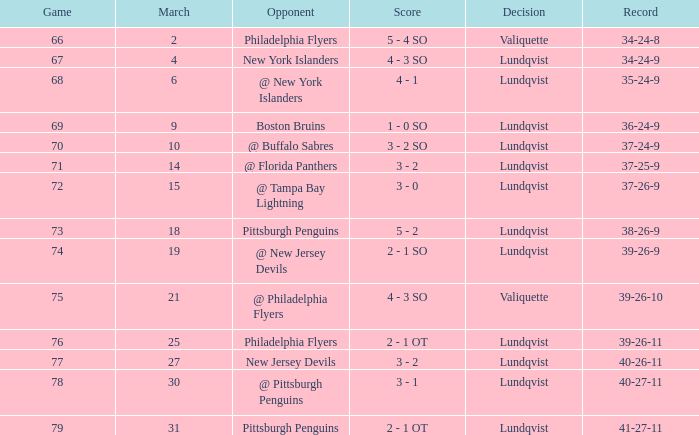Which opponent's game was less than 76 when the march was 10? @ Buffalo Sabres. 